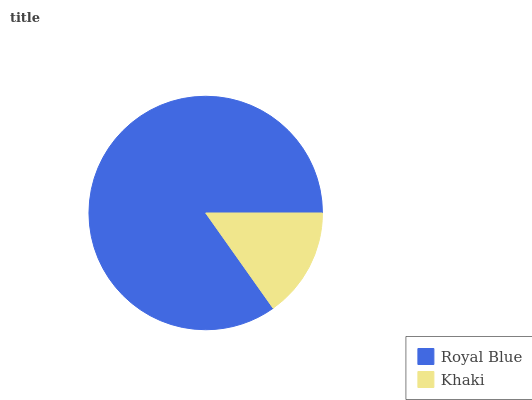Is Khaki the minimum?
Answer yes or no. Yes. Is Royal Blue the maximum?
Answer yes or no. Yes. Is Khaki the maximum?
Answer yes or no. No. Is Royal Blue greater than Khaki?
Answer yes or no. Yes. Is Khaki less than Royal Blue?
Answer yes or no. Yes. Is Khaki greater than Royal Blue?
Answer yes or no. No. Is Royal Blue less than Khaki?
Answer yes or no. No. Is Royal Blue the high median?
Answer yes or no. Yes. Is Khaki the low median?
Answer yes or no. Yes. Is Khaki the high median?
Answer yes or no. No. Is Royal Blue the low median?
Answer yes or no. No. 